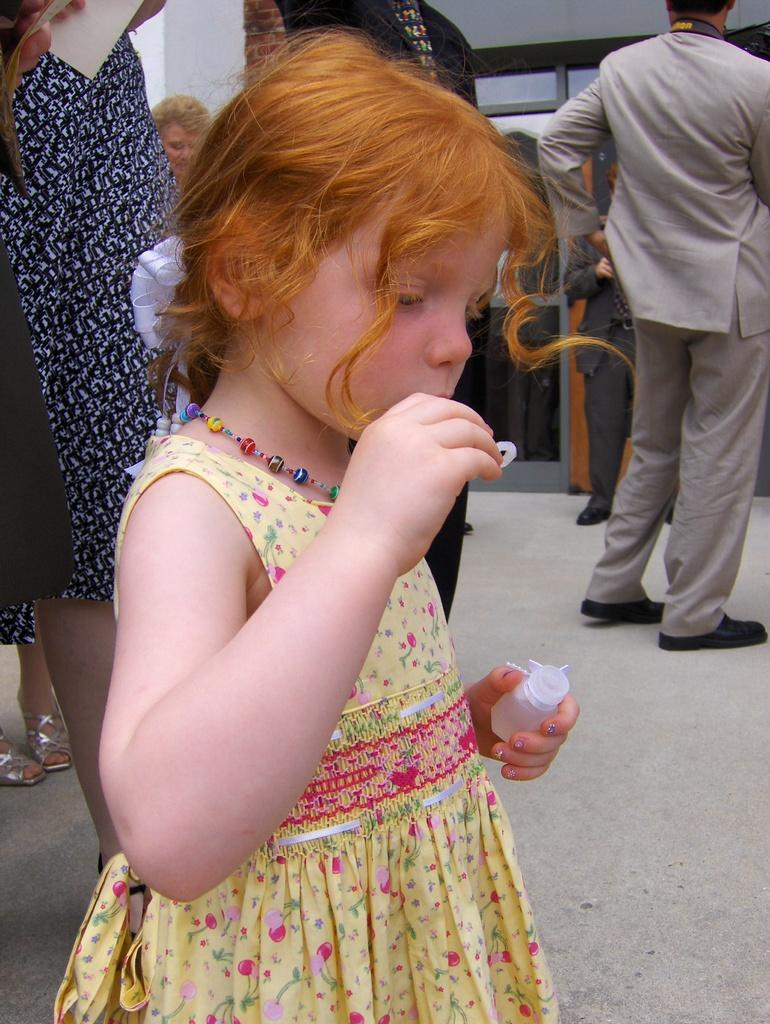Who is the main subject in the image? There is a girl in the image. What is the girl holding in her hand? The girl is holding a bottle in her hand. Can you describe the setting where the girl is located? There are people standing on the floor, and there is a wall in the background of the image. What type of material is visible in the background? There is glass in the background of the image. What type of thrill can be seen on the girl's face during the operation in the image? There is no operation or thrill present in the image; it features a girl holding a bottle with people standing nearby and a wall with glass in the background. 